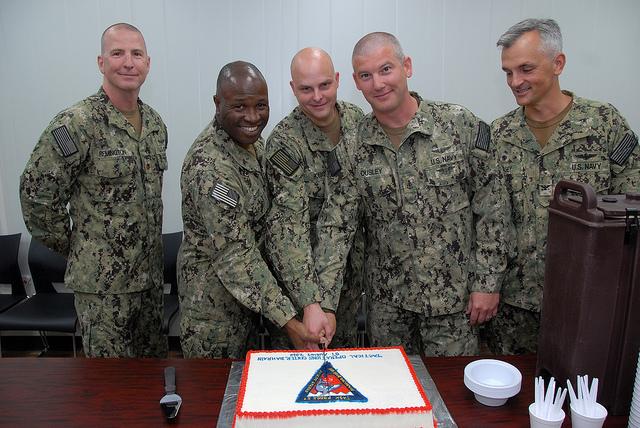Are these men in the army?
Quick response, please. Yes. Is this a party?
Give a very brief answer. Yes. What are they cutting?
Keep it brief. Cake. 